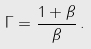<formula> <loc_0><loc_0><loc_500><loc_500>\Gamma = \frac { 1 + \beta } { \beta } \, .</formula> 